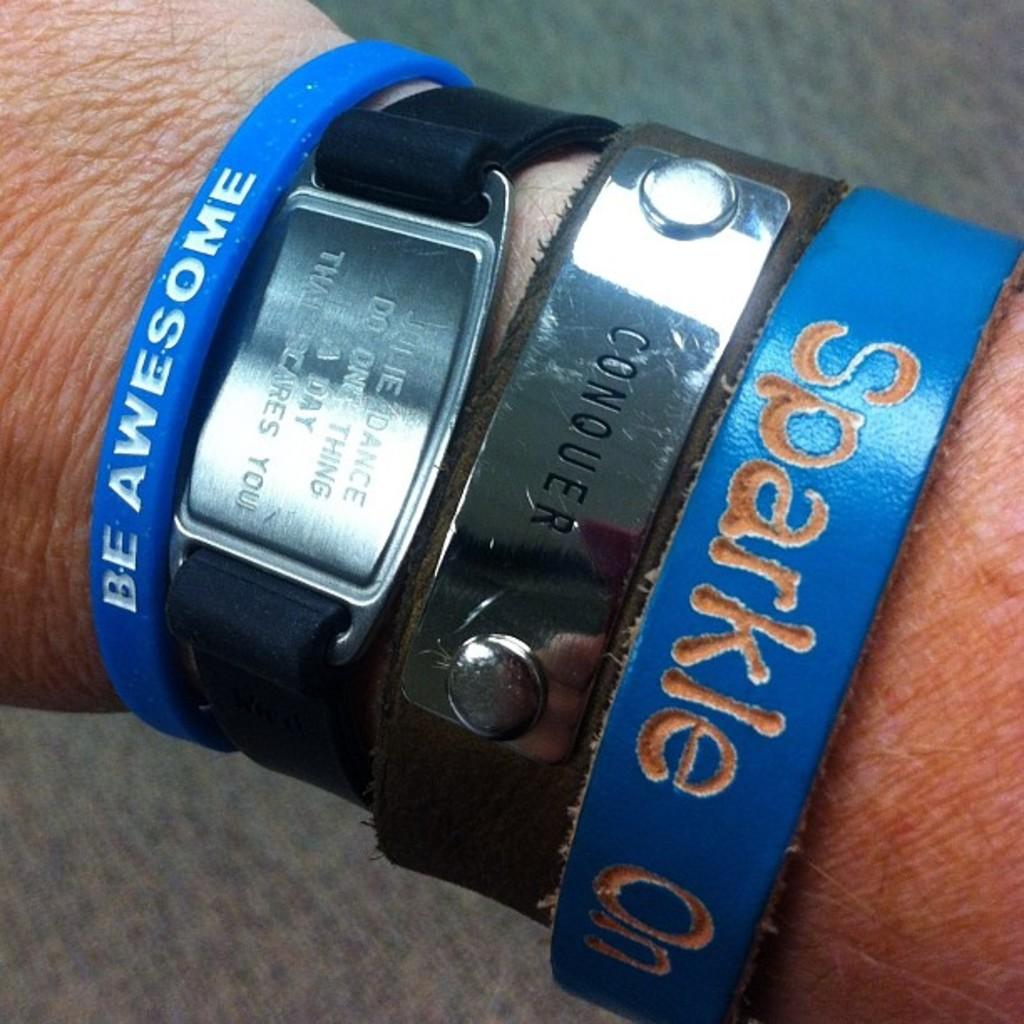<image>
Offer a succinct explanation of the picture presented. A person is wearing four different bracelets, all with inspirational sayings on them. 